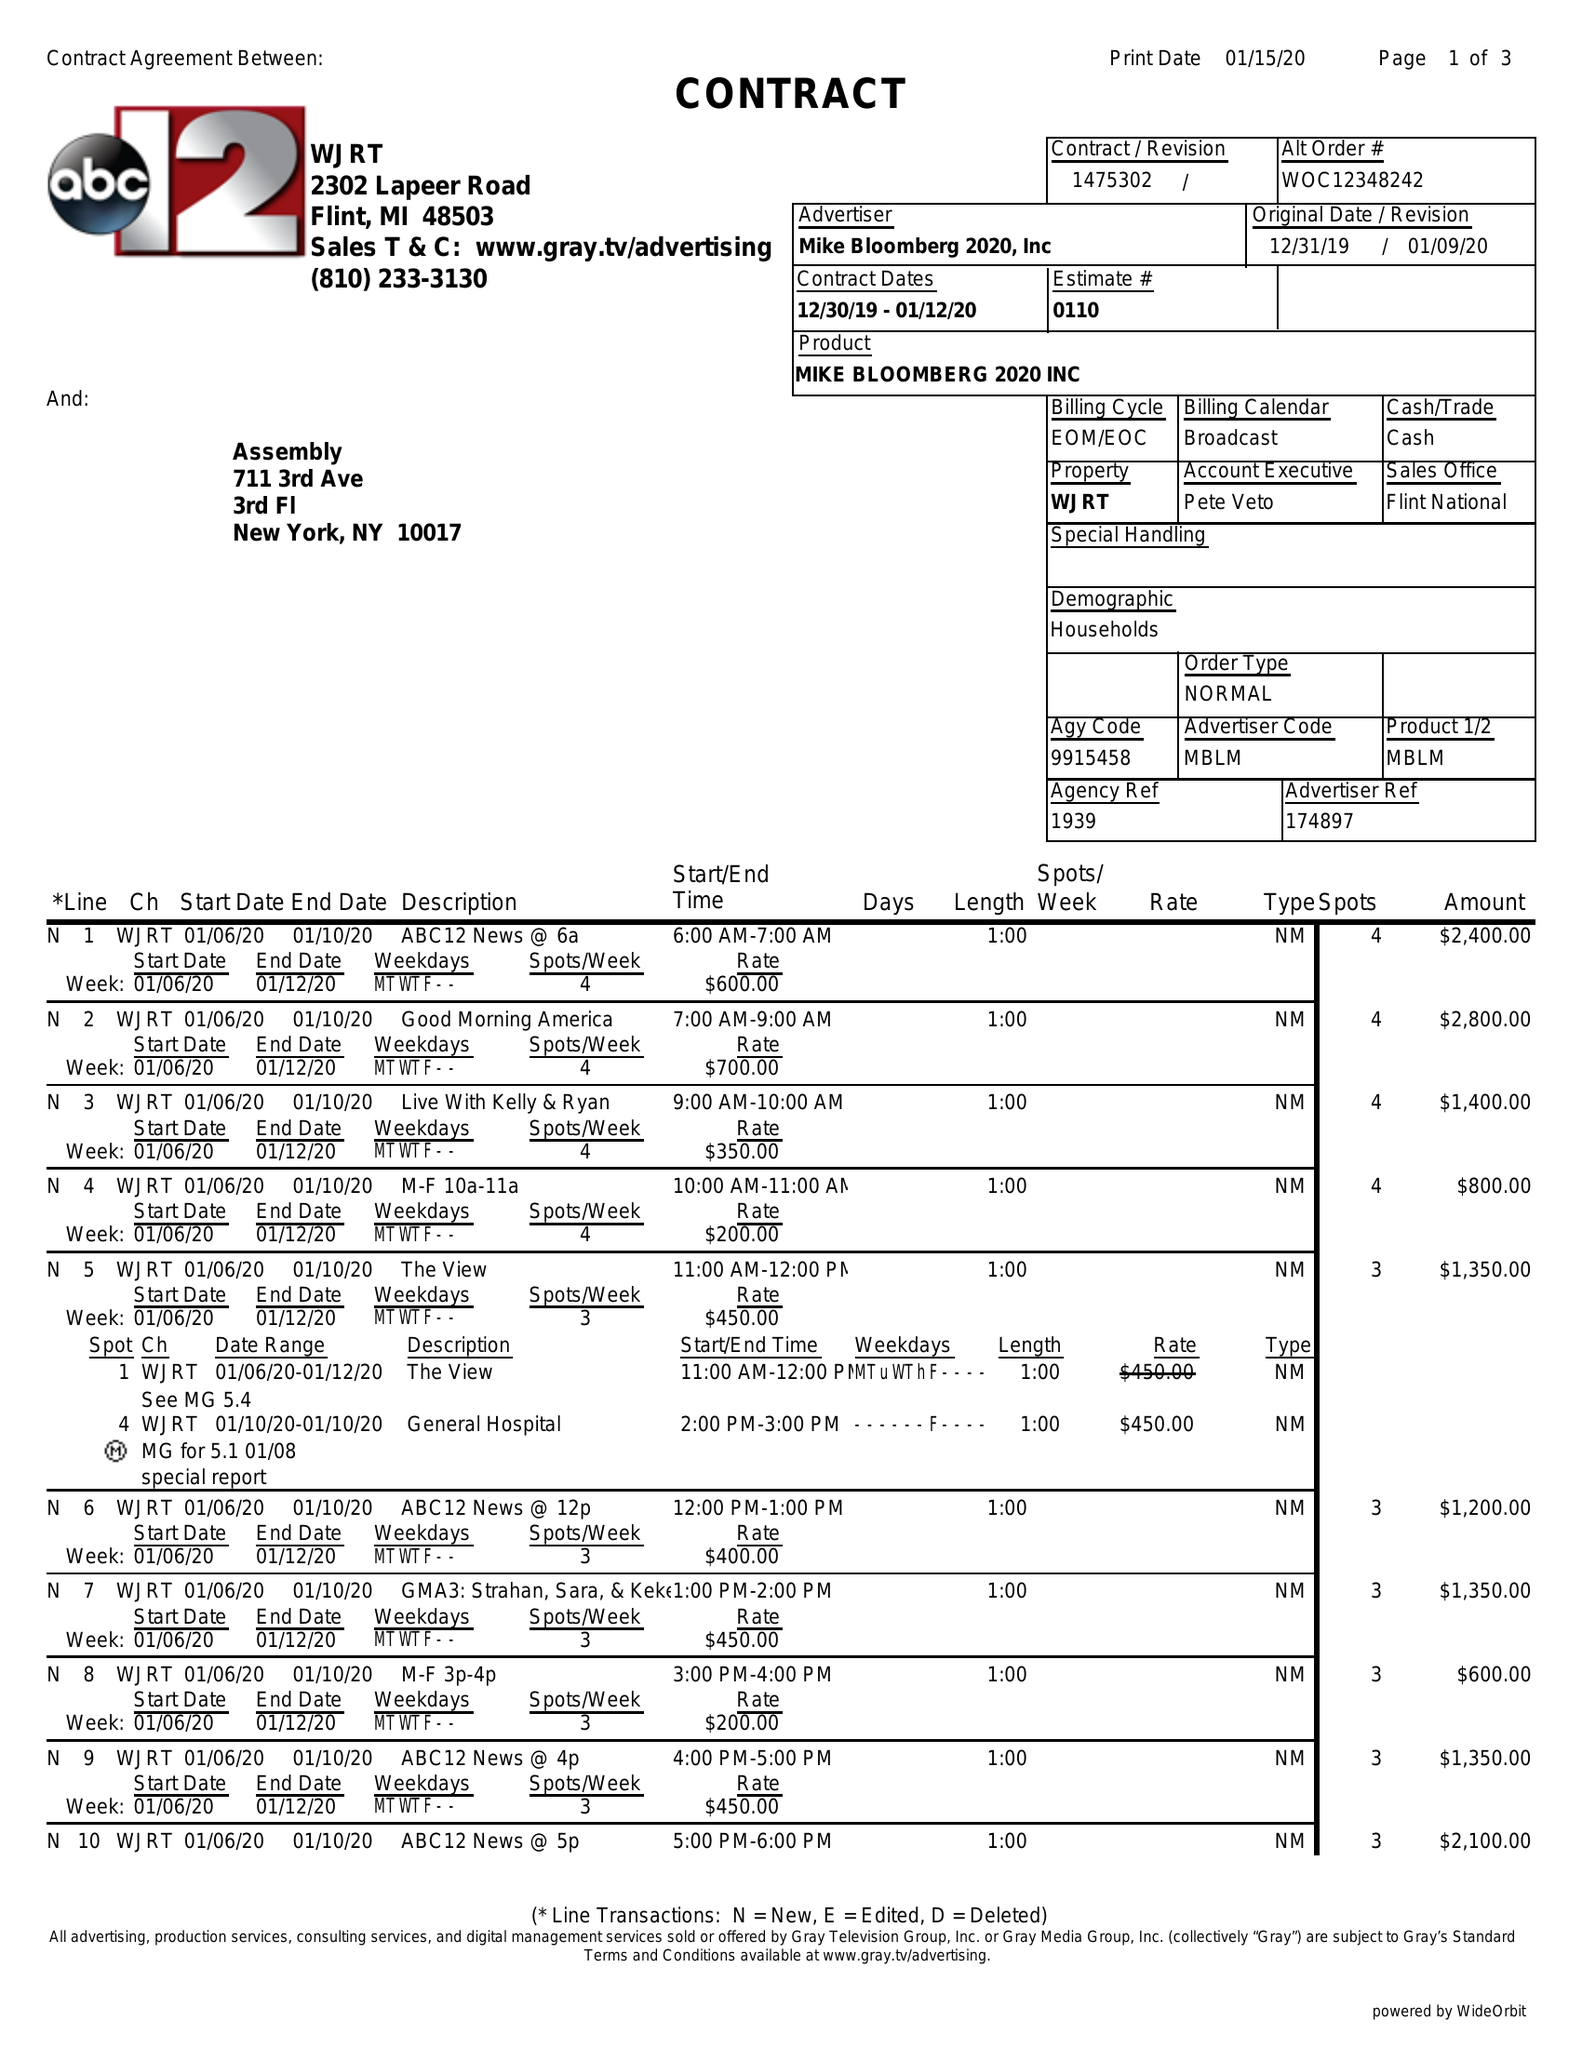What is the value for the flight_from?
Answer the question using a single word or phrase. 12/30/19 